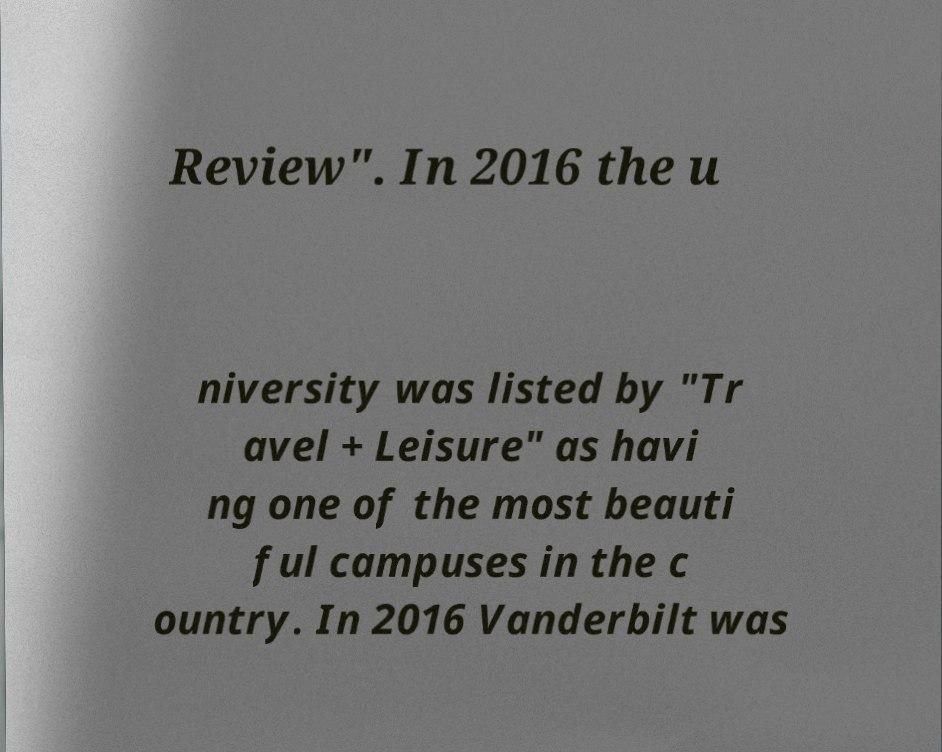For documentation purposes, I need the text within this image transcribed. Could you provide that? Review". In 2016 the u niversity was listed by "Tr avel + Leisure" as havi ng one of the most beauti ful campuses in the c ountry. In 2016 Vanderbilt was 